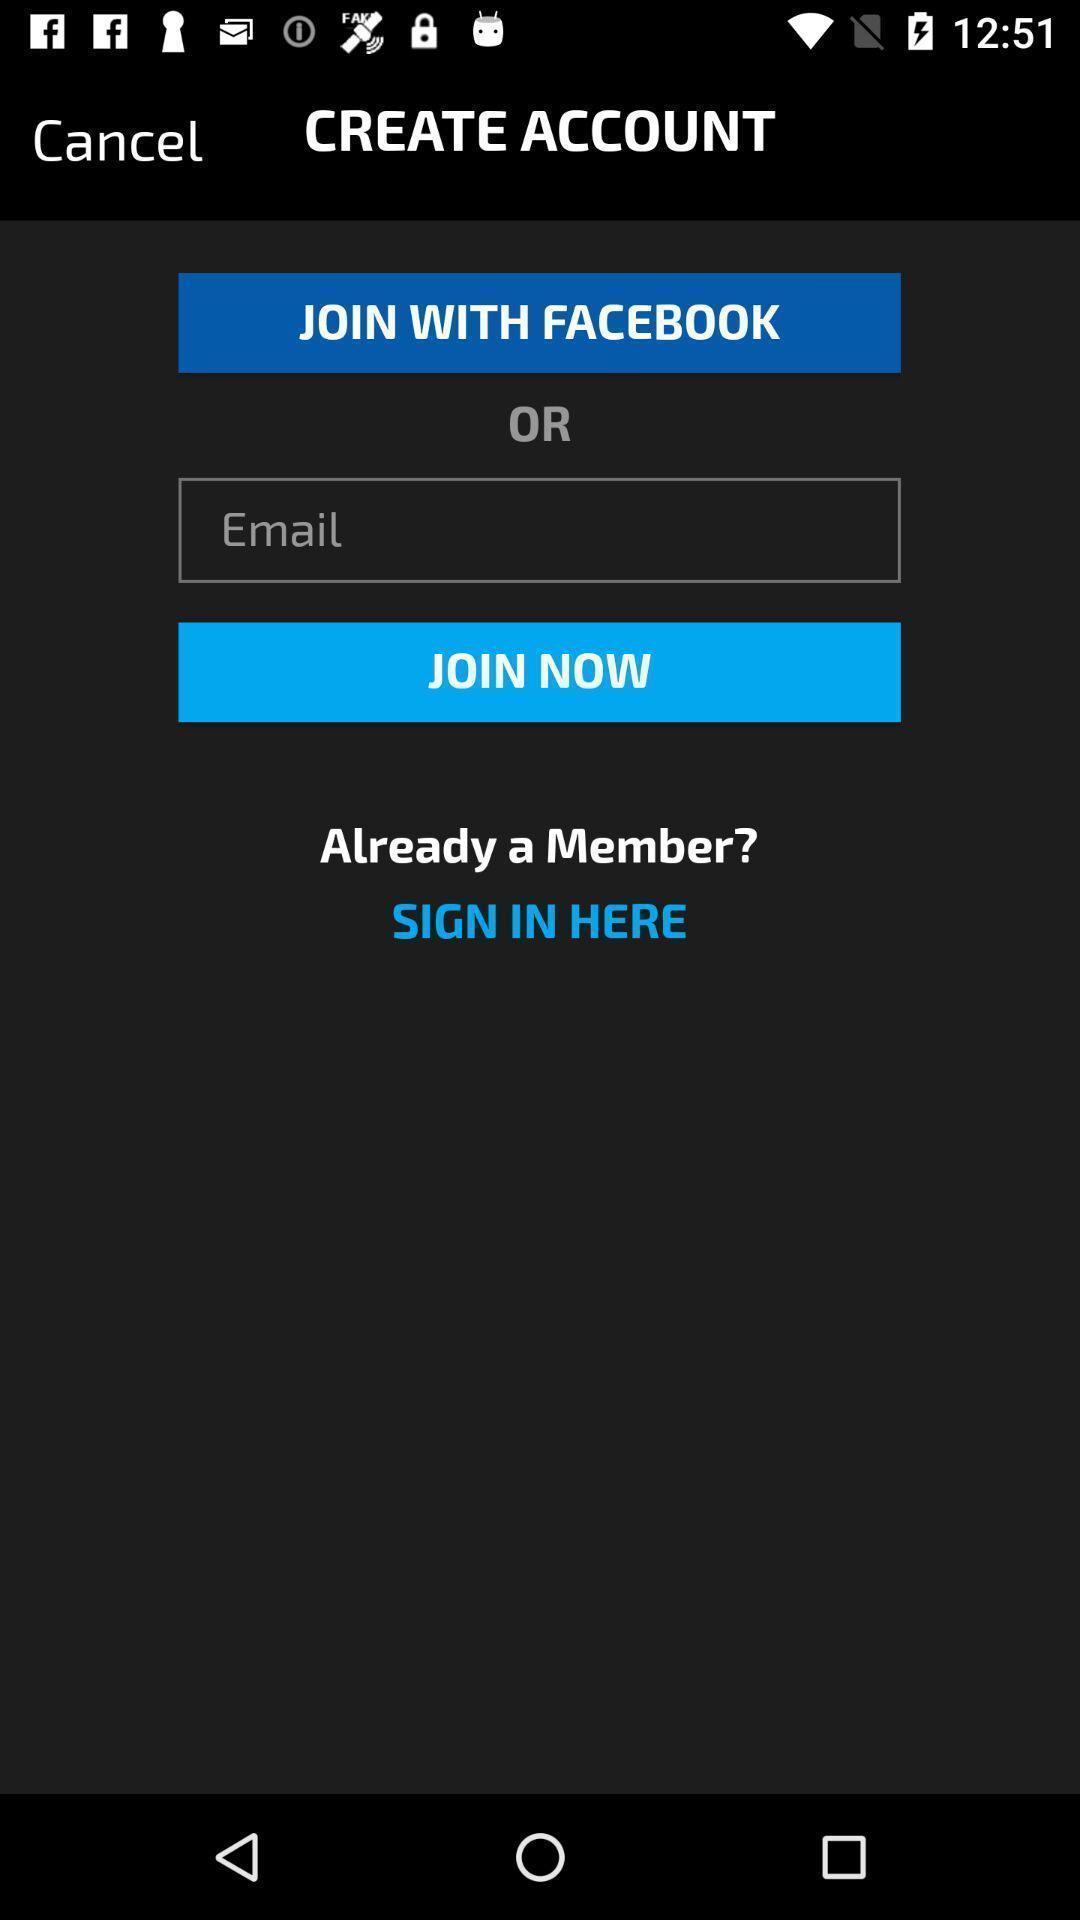Provide a description of this screenshot. Sign up/sign in page. 